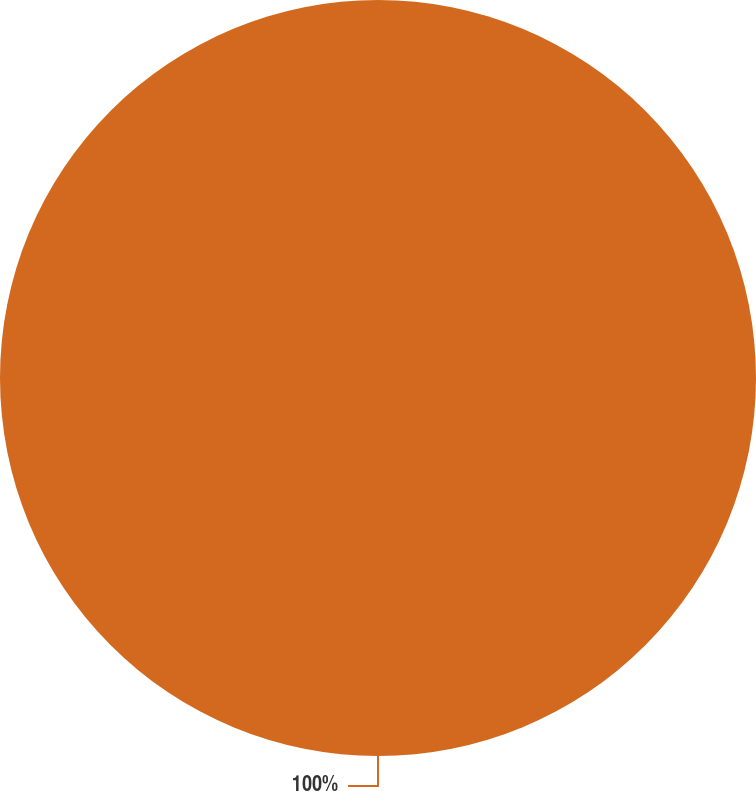Convert chart to OTSL. <chart><loc_0><loc_0><loc_500><loc_500><pie_chart><ecel><nl><fcel>100.0%<nl></chart> 